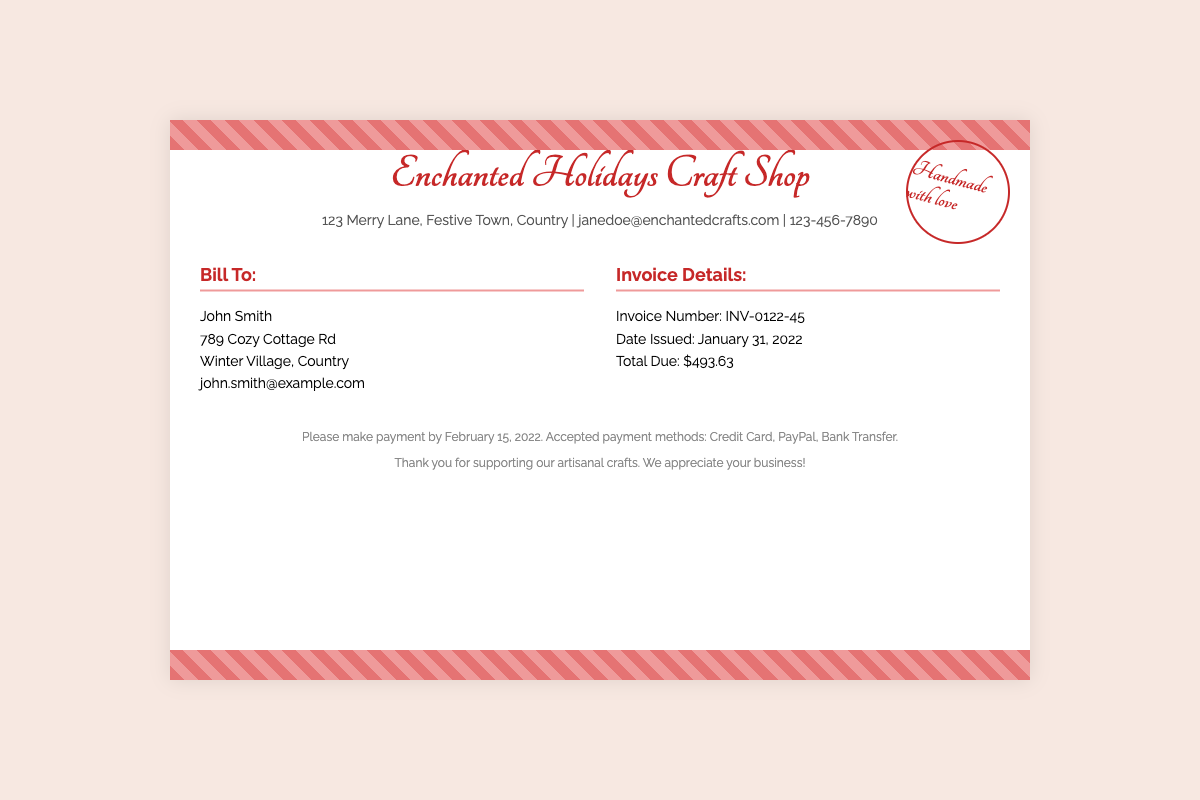What is the shop name? The shop name is prominently displayed at the top of the document.
Answer: Enchanted Holidays Craft Shop Who is the invoice addressed to? The "Bill To" section contains the recipient's name.
Answer: John Smith What is the total amount due? The total due is listed under the invoice details section.
Answer: $493.63 When was the invoice issued? The date issued is provided in the invoice details section.
Answer: January 31, 2022 What is the invoice number? The invoice number is found in the invoice details section.
Answer: INV-0122-45 By when should the payment be made? The deadline for payment is specified in the footer of the document.
Answer: February 15, 2022 What methods of payment are accepted? The accepted payment methods are listed in the footer of the document.
Answer: Credit Card, PayPal, Bank Transfer Where is the shop located? The shop's address is provided in the shop information section.
Answer: 123 Merry Lane, Festive Town, Country What is the stamp's text? The stamp's message is located in the corner of the envelope.
Answer: Handmade with love 